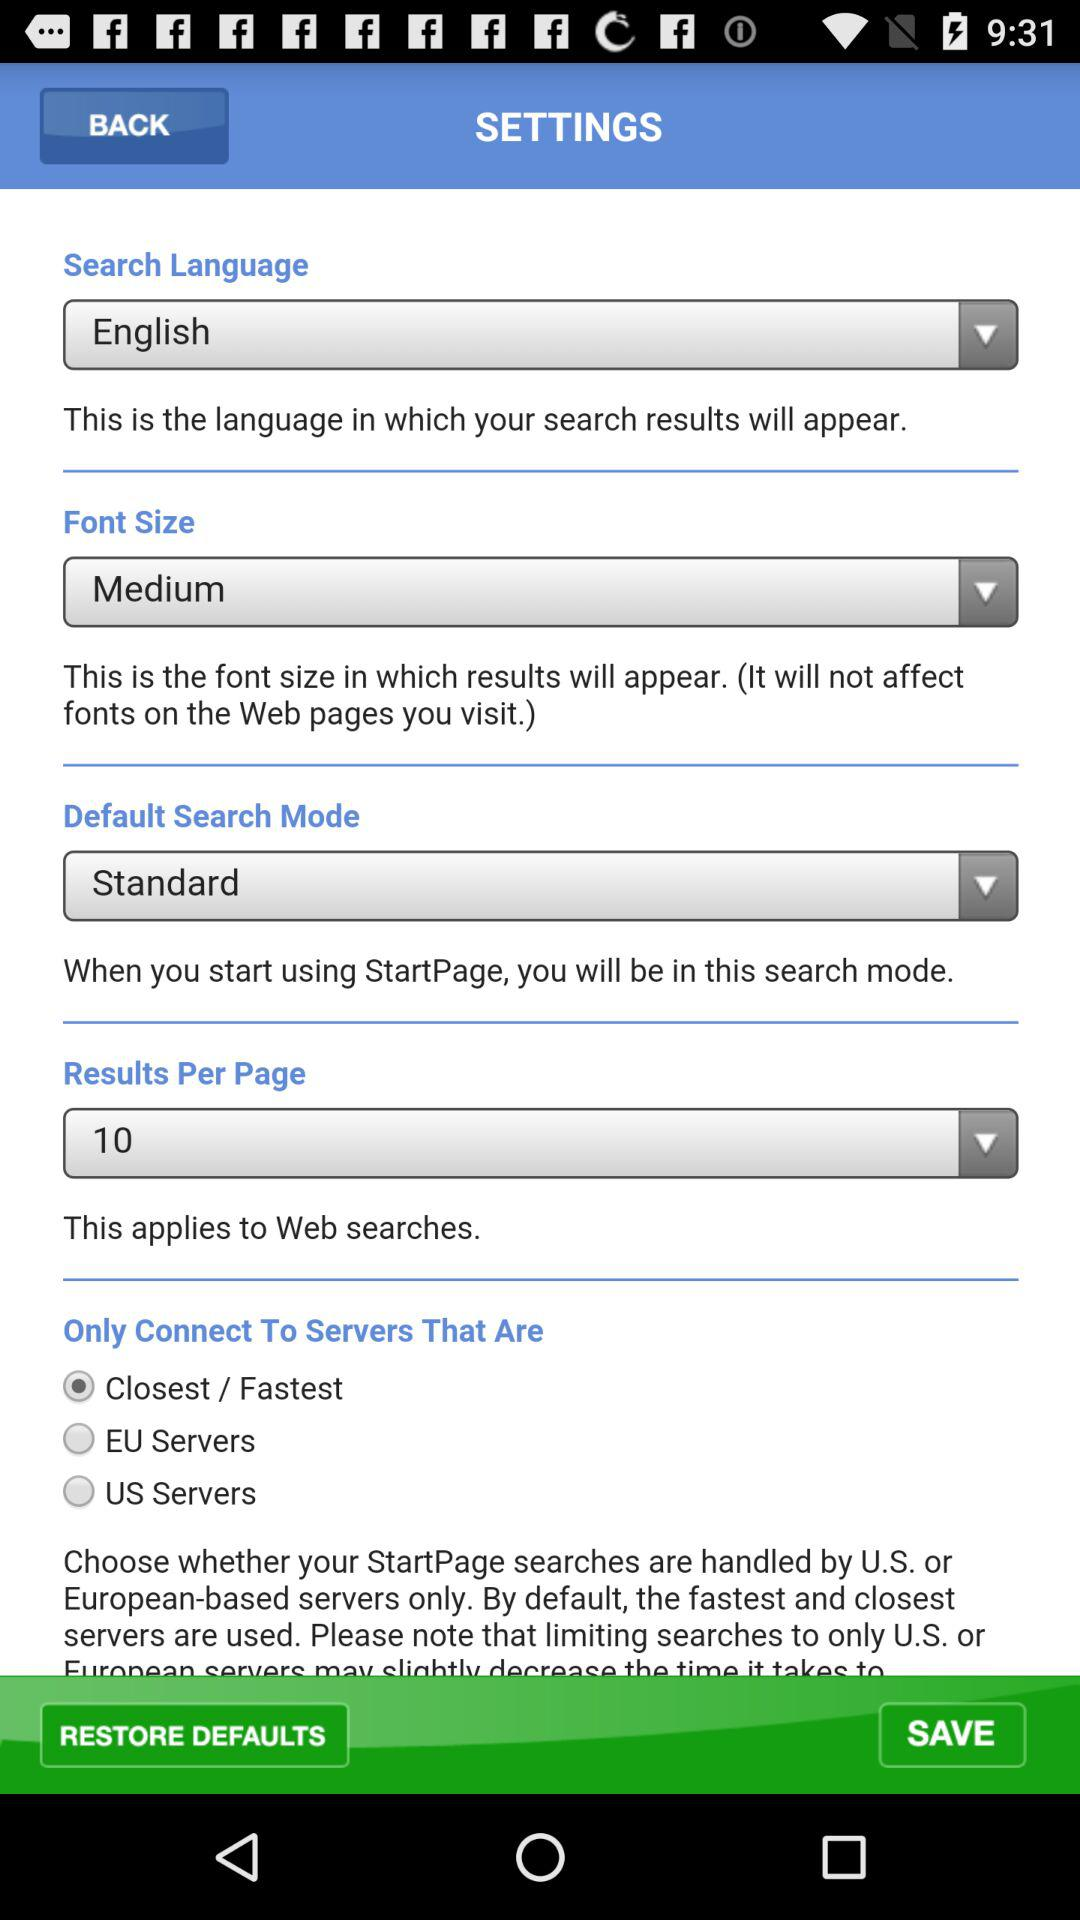What is the setting for "Results Per Page"? The setting is 10. 